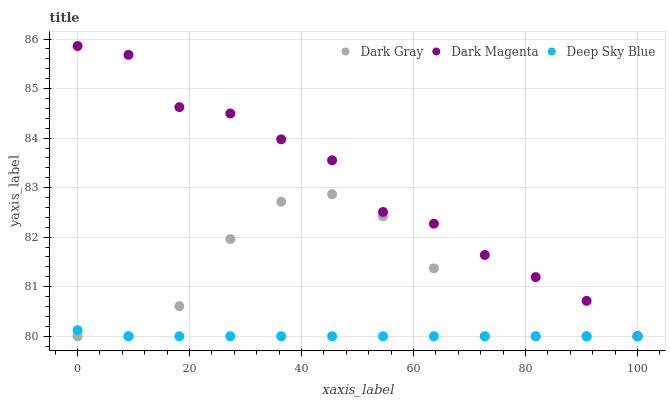Does Deep Sky Blue have the minimum area under the curve?
Answer yes or no. Yes. Does Dark Magenta have the maximum area under the curve?
Answer yes or no. Yes. Does Dark Magenta have the minimum area under the curve?
Answer yes or no. No. Does Deep Sky Blue have the maximum area under the curve?
Answer yes or no. No. Is Deep Sky Blue the smoothest?
Answer yes or no. Yes. Is Dark Gray the roughest?
Answer yes or no. Yes. Is Dark Magenta the smoothest?
Answer yes or no. No. Is Dark Magenta the roughest?
Answer yes or no. No. Does Dark Gray have the lowest value?
Answer yes or no. Yes. Does Dark Magenta have the highest value?
Answer yes or no. Yes. Does Deep Sky Blue have the highest value?
Answer yes or no. No. Does Dark Gray intersect Deep Sky Blue?
Answer yes or no. Yes. Is Dark Gray less than Deep Sky Blue?
Answer yes or no. No. Is Dark Gray greater than Deep Sky Blue?
Answer yes or no. No. 